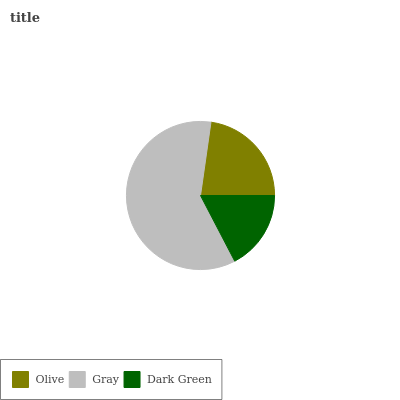Is Dark Green the minimum?
Answer yes or no. Yes. Is Gray the maximum?
Answer yes or no. Yes. Is Gray the minimum?
Answer yes or no. No. Is Dark Green the maximum?
Answer yes or no. No. Is Gray greater than Dark Green?
Answer yes or no. Yes. Is Dark Green less than Gray?
Answer yes or no. Yes. Is Dark Green greater than Gray?
Answer yes or no. No. Is Gray less than Dark Green?
Answer yes or no. No. Is Olive the high median?
Answer yes or no. Yes. Is Olive the low median?
Answer yes or no. Yes. Is Gray the high median?
Answer yes or no. No. Is Gray the low median?
Answer yes or no. No. 